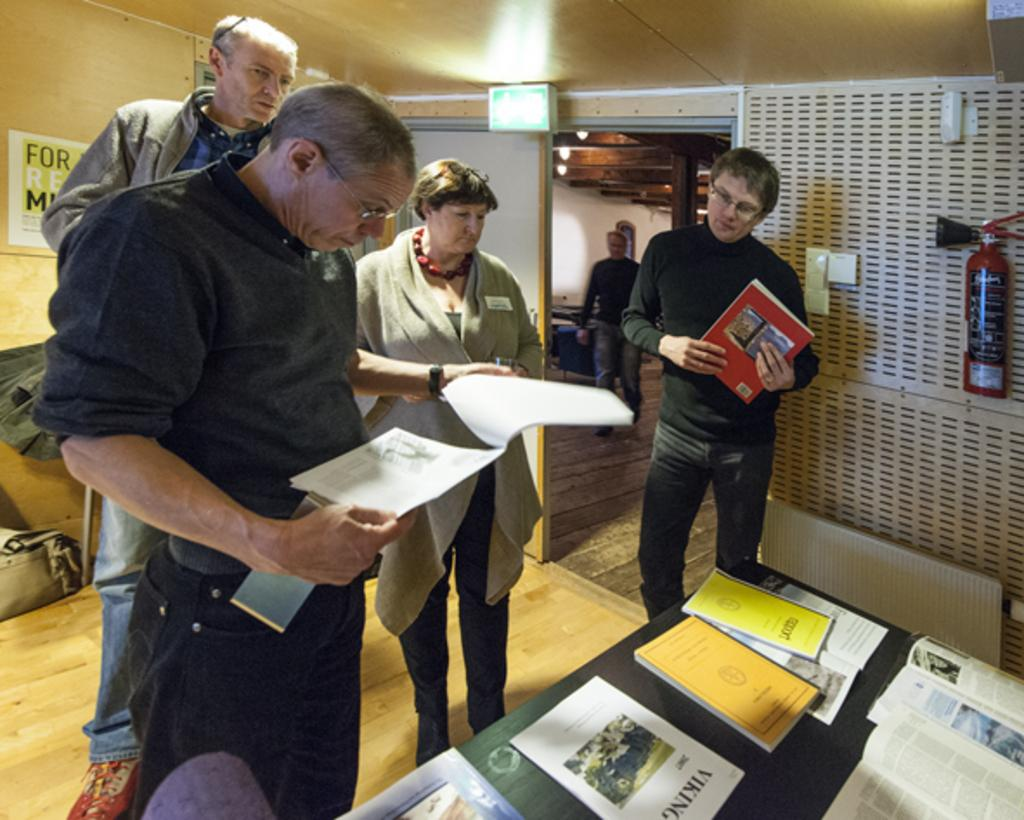<image>
Share a concise interpretation of the image provided. A group of people looking at books, one of which is about vikings 